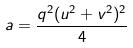Convert formula to latex. <formula><loc_0><loc_0><loc_500><loc_500>a = \frac { q ^ { 2 } ( u ^ { 2 } + v ^ { 2 } ) ^ { 2 } } { 4 }</formula> 